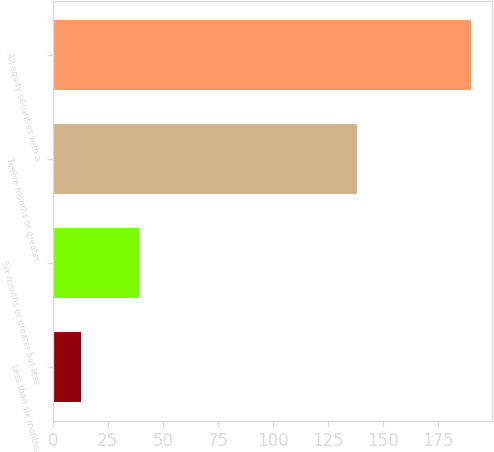Convert chart to OTSL. <chart><loc_0><loc_0><loc_500><loc_500><bar_chart><fcel>Less than six months<fcel>Six months or greater but less<fcel>Twelve months or greater<fcel>All equity securities with a<nl><fcel>13<fcel>39<fcel>138<fcel>190<nl></chart> 